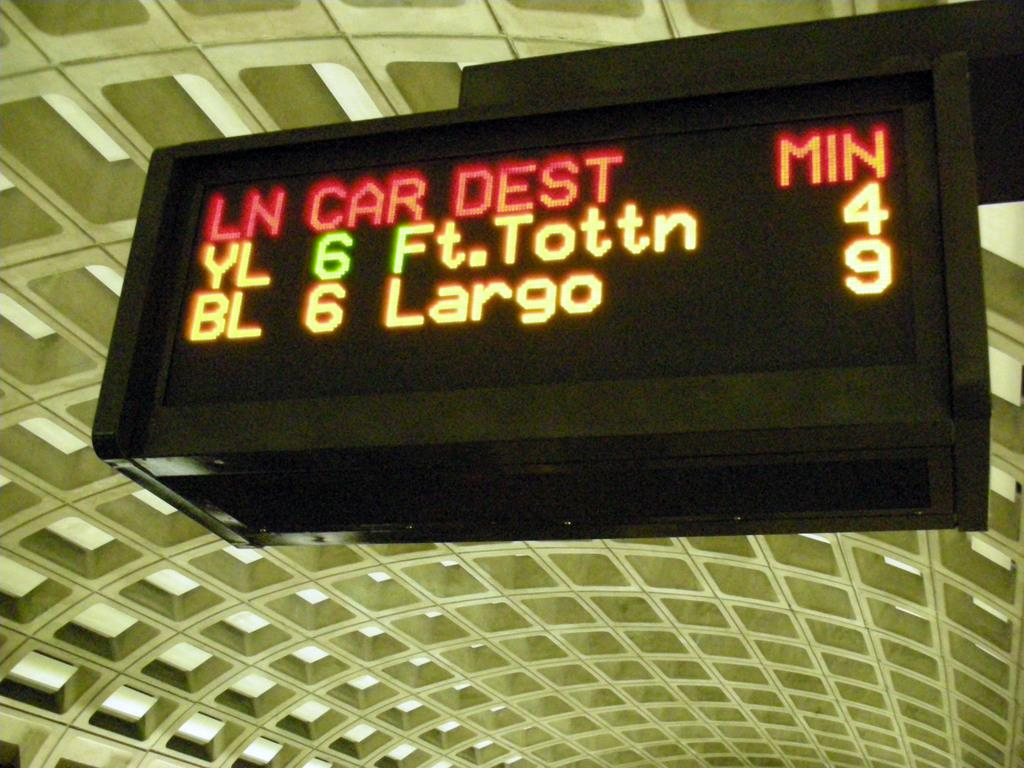<image>
Provide a brief description of the given image. a scoreboard with the numbers 4 and 9 on it 